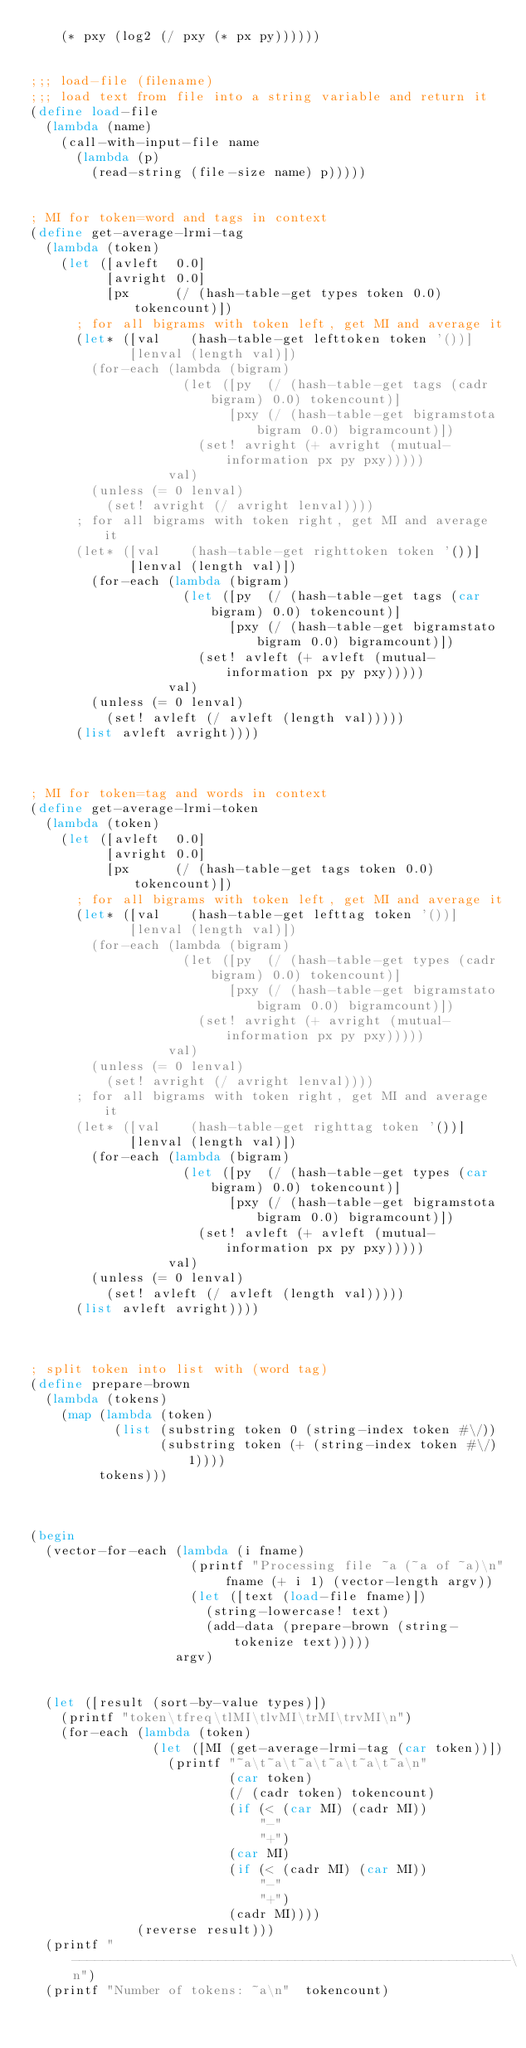Convert code to text. <code><loc_0><loc_0><loc_500><loc_500><_Scheme_>    (* pxy (log2 (/ pxy (* px py))))))


;;; load-file (filename)
;;; load text from file into a string variable and return it
(define load-file
  (lambda (name)
    (call-with-input-file name
      (lambda (p)
        (read-string (file-size name) p)))))


; MI for token=word and tags in context
(define get-average-lrmi-tag
  (lambda (token)
    (let ([avleft  0.0]
          [avright 0.0]
          [px      (/ (hash-table-get types token 0.0) tokencount)])
      ; for all bigrams with token left, get MI and average it
      (let* ([val    (hash-table-get lefttoken token '())]
             [lenval (length val)])
        (for-each (lambda (bigram)
                    (let ([py  (/ (hash-table-get tags (cadr bigram) 0.0) tokencount)]
                          [pxy (/ (hash-table-get bigramstota bigram 0.0) bigramcount)])
                      (set! avright (+ avright (mutual-information px py pxy)))))
                  val)
        (unless (= 0 lenval)
          (set! avright (/ avright lenval))))
      ; for all bigrams with token right, get MI and average it
      (let* ([val    (hash-table-get righttoken token '())]
             [lenval (length val)])
        (for-each (lambda (bigram)
                    (let ([py  (/ (hash-table-get tags (car bigram) 0.0) tokencount)]
                          [pxy (/ (hash-table-get bigramstato bigram 0.0) bigramcount)])
                      (set! avleft (+ avleft (mutual-information px py pxy)))))
                  val)
        (unless (= 0 lenval)
          (set! avleft (/ avleft (length val)))))
      (list avleft avright))))



; MI for token=tag and words in context
(define get-average-lrmi-token
  (lambda (token)
    (let ([avleft  0.0]
          [avright 0.0]
          [px      (/ (hash-table-get tags token 0.0) tokencount)])
      ; for all bigrams with token left, get MI and average it
      (let* ([val    (hash-table-get lefttag token '())]
             [lenval (length val)])
        (for-each (lambda (bigram)
                    (let ([py  (/ (hash-table-get types (cadr bigram) 0.0) tokencount)]
                          [pxy (/ (hash-table-get bigramstato bigram 0.0) bigramcount)])
                      (set! avright (+ avright (mutual-information px py pxy)))))
                  val)
        (unless (= 0 lenval)
          (set! avright (/ avright lenval))))
      ; for all bigrams with token right, get MI and average it
      (let* ([val    (hash-table-get righttag token '())]
             [lenval (length val)])
        (for-each (lambda (bigram)
                    (let ([py  (/ (hash-table-get types (car bigram) 0.0) tokencount)]
                          [pxy (/ (hash-table-get bigramstota bigram 0.0) bigramcount)])
                      (set! avleft (+ avleft (mutual-information px py pxy)))))
                  val)
        (unless (= 0 lenval)
          (set! avleft (/ avleft (length val)))))
      (list avleft avright))))



; split token into list with (word tag)
(define prepare-brown
  (lambda (tokens)
    (map (lambda (token)
           (list (substring token 0 (string-index token #\/))
                 (substring token (+ (string-index token #\/) 1))))
         tokens)))



(begin
  (vector-for-each (lambda (i fname)
                     (printf "Processing file ~a (~a of ~a)\n" fname (+ i 1) (vector-length argv))
                     (let ([text (load-file fname)])
                       (string-lowercase! text)
                       (add-data (prepare-brown (string-tokenize text)))))
                   argv)
  
  
  (let ([result (sort-by-value types)])
    (printf "token\tfreq\tlMI\tlvMI\trMI\trvMI\n")
    (for-each (lambda (token)
                (let ([MI (get-average-lrmi-tag (car token))])
                  (printf "~a\t~a\t~a\t~a\t~a\t~a\n"
                          (car token)
                          (/ (cadr token) tokencount)
                          (if (< (car MI) (cadr MI))
                              "-"
                              "+")
                          (car MI)
                          (if (< (cadr MI) (car MI))
                              "-"
                              "+")
                          (cadr MI))))
              (reverse result)))
  (printf "---------------------------------------------------------\n")
  (printf "Number of tokens: ~a\n"  tokencount)</code> 